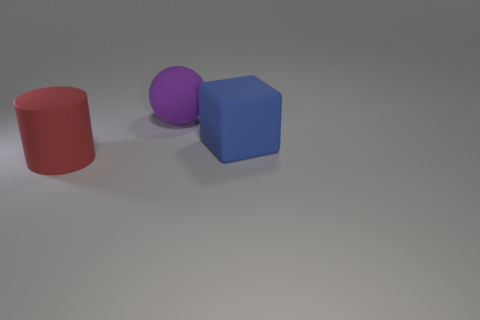Add 2 purple objects. How many objects exist? 5 Subtract all spheres. How many objects are left? 2 Subtract all red rubber cylinders. Subtract all balls. How many objects are left? 1 Add 3 red matte things. How many red matte things are left? 4 Add 3 matte cylinders. How many matte cylinders exist? 4 Subtract 0 cyan balls. How many objects are left? 3 